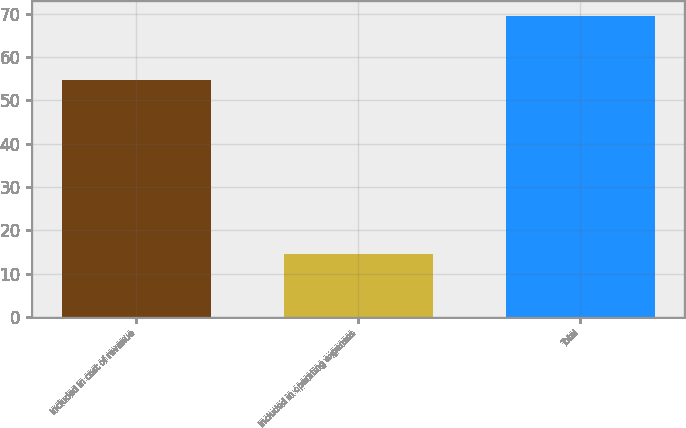Convert chart to OTSL. <chart><loc_0><loc_0><loc_500><loc_500><bar_chart><fcel>Included in cost of revenue<fcel>Included in operating expenses<fcel>Total<nl><fcel>54.8<fcel>14.6<fcel>69.4<nl></chart> 